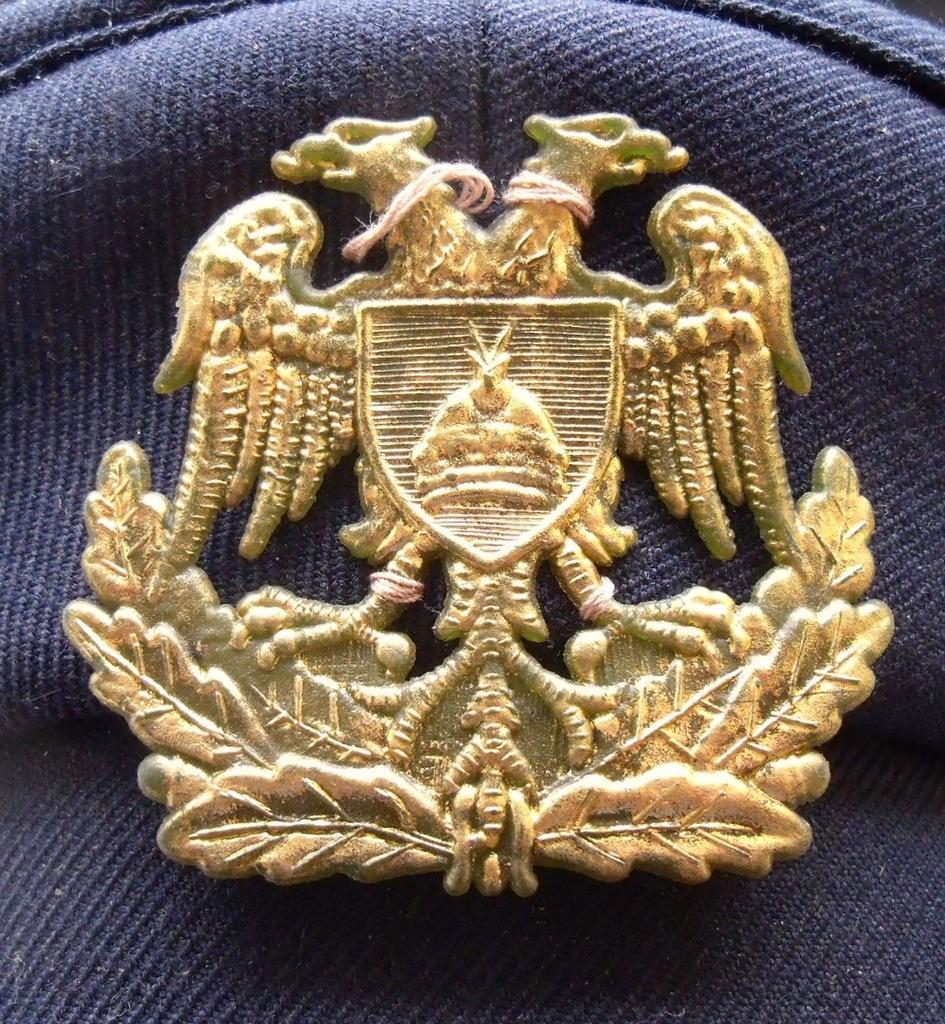Can you describe this image briefly? There is a badge on a blue cloth. 